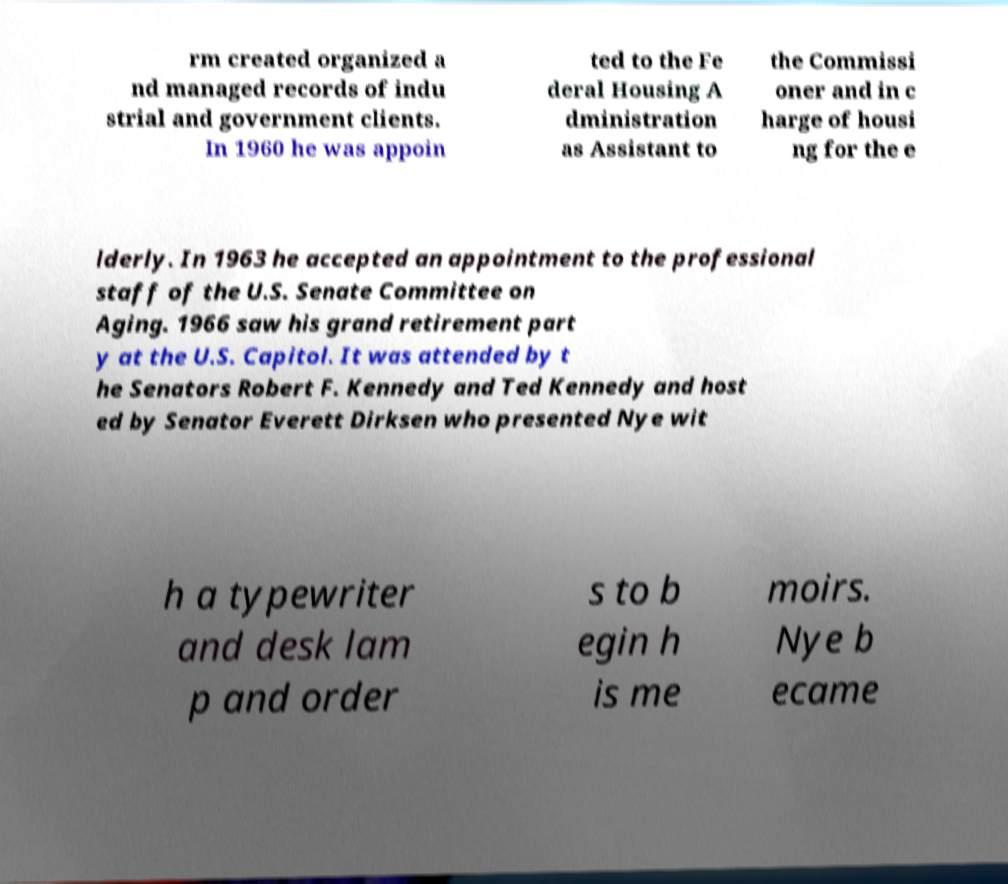Please read and relay the text visible in this image. What does it say? rm created organized a nd managed records of indu strial and government clients. In 1960 he was appoin ted to the Fe deral Housing A dministration as Assistant to the Commissi oner and in c harge of housi ng for the e lderly. In 1963 he accepted an appointment to the professional staff of the U.S. Senate Committee on Aging. 1966 saw his grand retirement part y at the U.S. Capitol. It was attended by t he Senators Robert F. Kennedy and Ted Kennedy and host ed by Senator Everett Dirksen who presented Nye wit h a typewriter and desk lam p and order s to b egin h is me moirs. Nye b ecame 